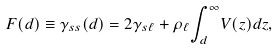Convert formula to latex. <formula><loc_0><loc_0><loc_500><loc_500>F ( d ) \equiv \gamma _ { s s } ( d ) = 2 \gamma _ { s { \ell } } + \rho _ { \ell } { \int _ { d } ^ { \infty } } V ( z ) d z ,</formula> 